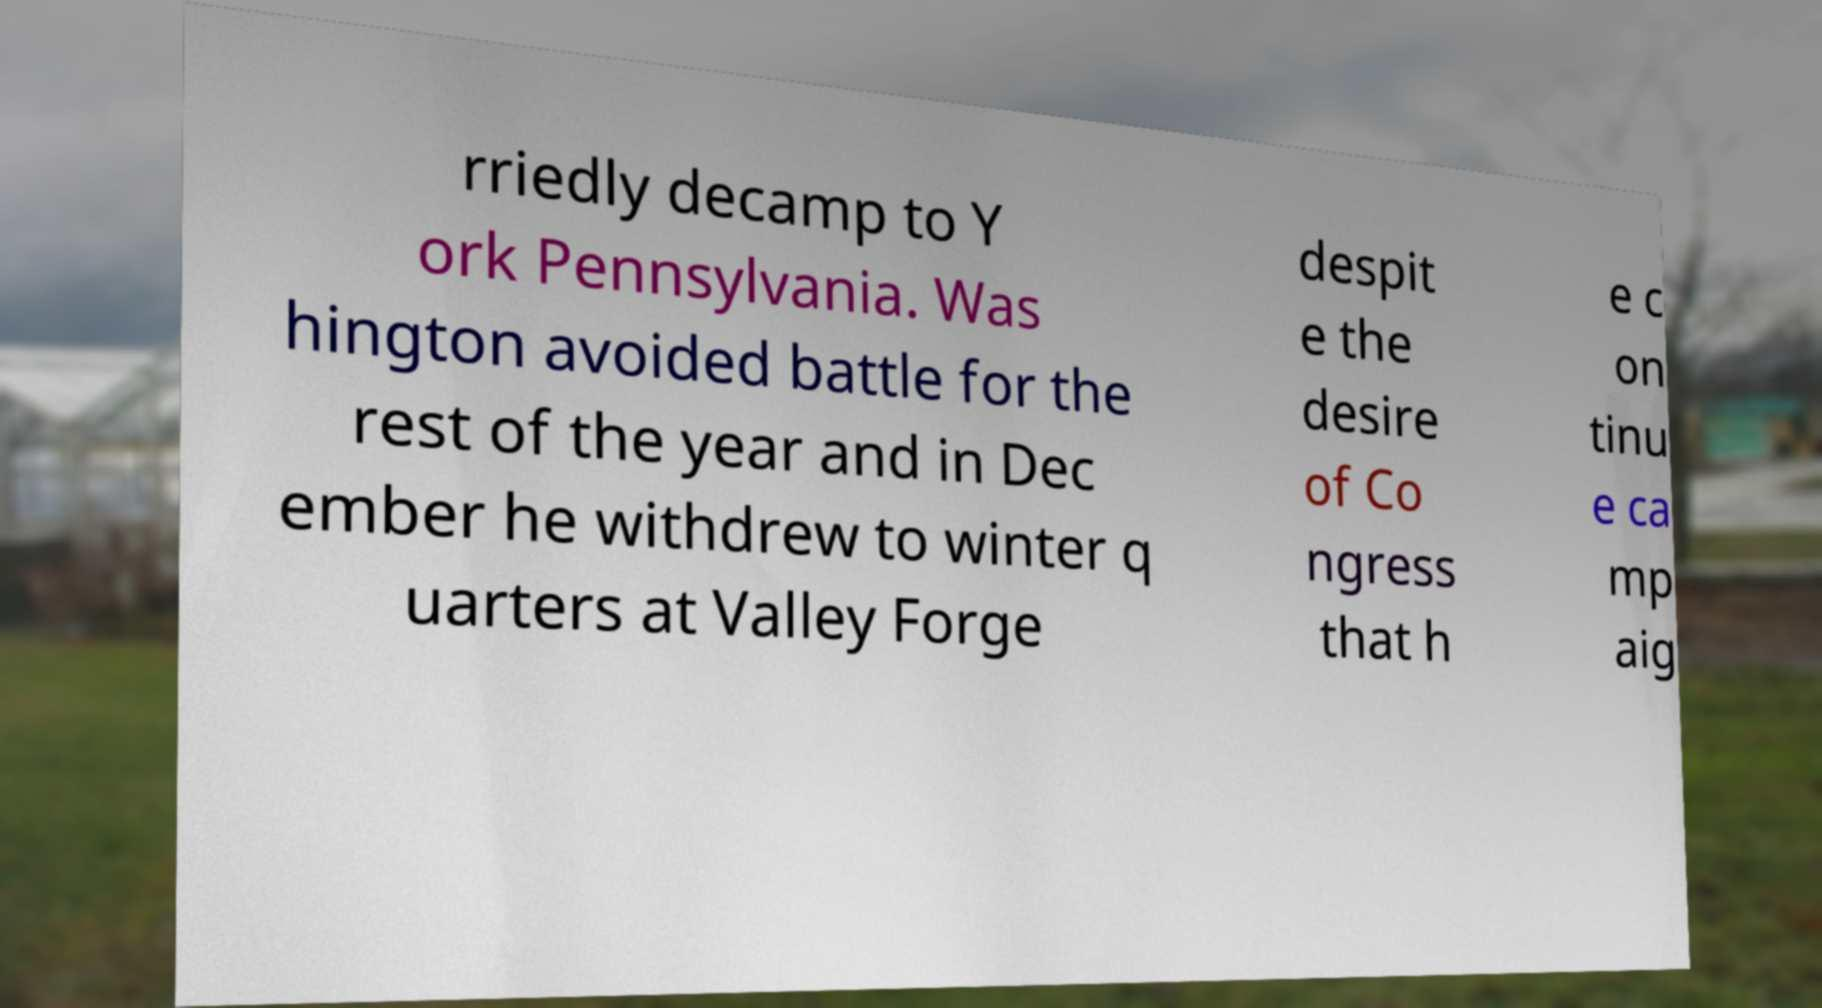For documentation purposes, I need the text within this image transcribed. Could you provide that? rriedly decamp to Y ork Pennsylvania. Was hington avoided battle for the rest of the year and in Dec ember he withdrew to winter q uarters at Valley Forge despit e the desire of Co ngress that h e c on tinu e ca mp aig 